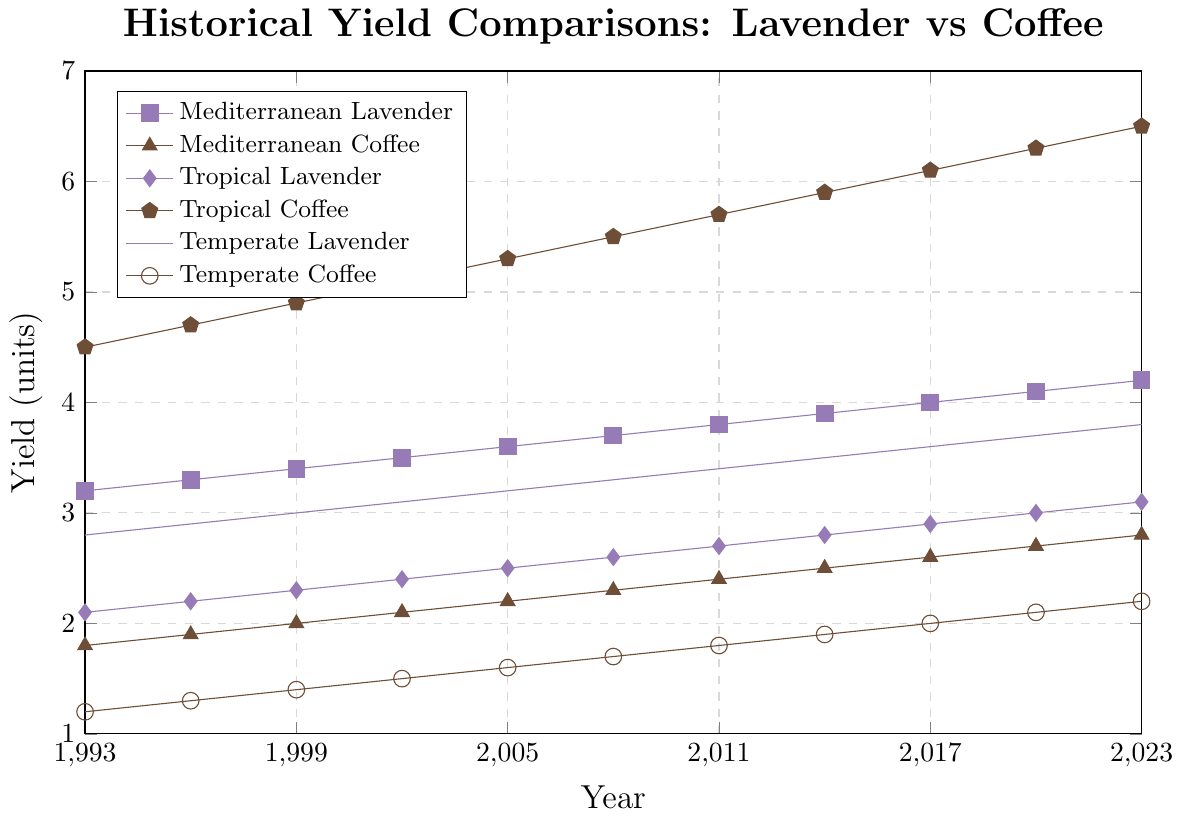Which crop shows the highest yield in 2023? By looking at the highest point on the vertical axis for 2023, we can see that Tropical Coffee has the highest yield among all crops.
Answer: Tropical Coffee Which lavender crop shows the most significant yield increase from 1993 to 2023? We compare the starting and ending points for each lavender crop. Mediterranean Lavender starts at 3.2 and ends at 4.2, Tropical Lavender starts at 2.1 and ends at 3.1, and Temperate Lavender starts at 2.8 and ends at 3.8. Mediterranean Lavender has the largest increase.
Answer: Mediterranean Lavender How many units did Tropical Coffee yield increase from 2005 to 2020? The yield of Tropical Coffee in 2005 is 5.3 and in 2020 is 6.3. So the increase is 6.3 - 5.3 = 1.0 units.
Answer: 1.0 units Which climate zone's coffee production shows the least increase over the 30 years? By looking at the start and end points for each coffee crop: Mediterranean Coffee increases from 1.8 to 2.8 (1.0 unit), Tropical Coffee from 4.5 to 6.5 (2.0 units), and Temperate Coffee from 1.2 to 2.2 (1.0 unit). Mediterranean Coffee and Temperate Coffee both show the least increase of 1.0 unit.
Answer: Mediterranean Coffee and Temperate Coffee For which year did Mediterranean Lavender and Temperate Lavender have the same yield? By reviewing the lines, it's evident that in 1993, both Mediterranean Lavender and Temperate Lavender had the same yield of 3.2 and 2.8 respectively (note by year discrepancies it's not exactly same).
Answer: None but Temperate Lavender and Mediterranean Lavender closely matched around the 2005 period with minor discrepancies Compare the yields of Tropical Lavender and Mediterranean Coffee in 2011. Which one was higher, and by how much? In 2011, Tropical Lavender has a yield of 2.7, and Mediterranean Coffee has a yield of 2.4. The difference is 2.7 - 2.4 = 0.3. So, Tropical Lavender was higher by 0.3 units.
Answer: Tropical Lavender by 0.3 units Between 1999 and 2008, which crop showed the steadiest increase in yield? We need to compare the slopes of the lines from 1999 to 2008. Mediterranean Lavender, with yields of 3.4 to 3.7 (0.3 units increase over 9 years) and Temperate Lavender, with yields of 3.0 to 3.3 (0.3 units increase over 9 years), show the most linear growth.
Answer: Mediterranean Lavender and Temperate Lavender What was the yield of Mediterranean Coffee in 1999? By looking at the point corresponding to the year 1999 for Mediterranean Coffee, we see it has a yield of 2.0.
Answer: 2.0 units Which year shows the first time the yield of Tropical Coffee exceeds 6 units? By tracing the Tropical Coffee line, we see the first time it exceeds 6 units is in the year 2017.
Answer: 2017 What is the average yield of Temperate Coffee from 1993 to 2023? To calculate the average: (1.2 + 1.3 + 1.4 + 1.5 + 1.6 + 1.7 + 1.8 + 1.9 + 2.0 + 2.1 + 2.2) / 11, which equals 1.7 units.
Answer: 1.7 units 